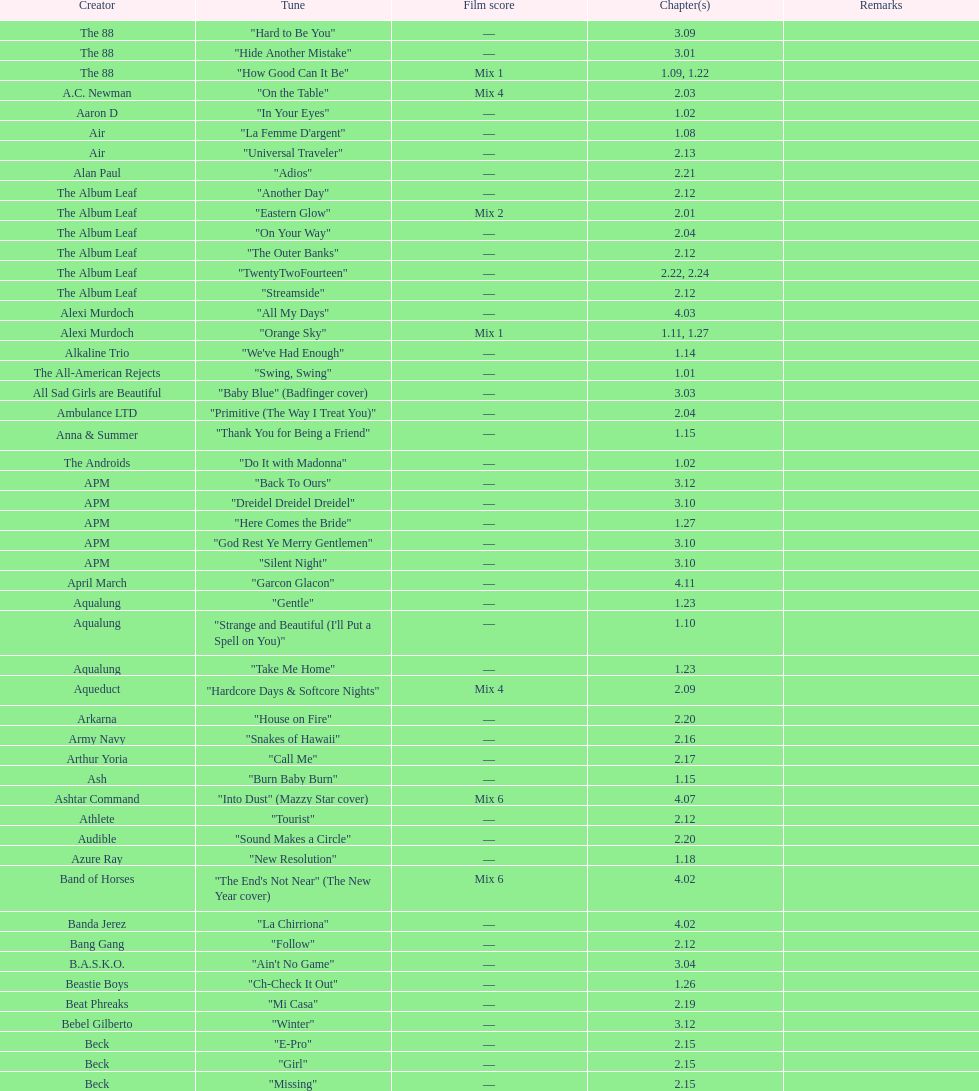How many consecutive songs were by the album leaf? 6. 